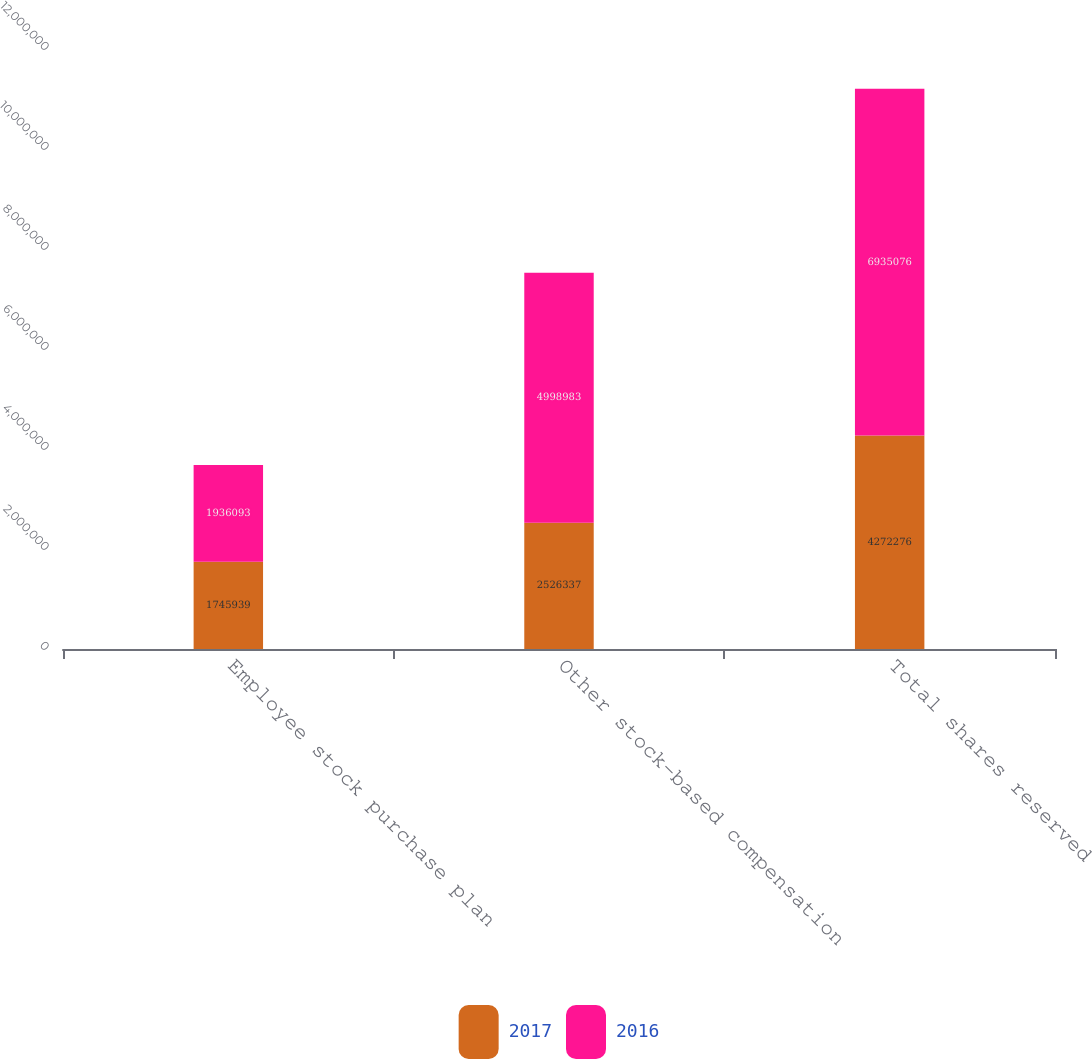Convert chart. <chart><loc_0><loc_0><loc_500><loc_500><stacked_bar_chart><ecel><fcel>Employee stock purchase plan<fcel>Other stock-based compensation<fcel>Total shares reserved<nl><fcel>2017<fcel>1.74594e+06<fcel>2.52634e+06<fcel>4.27228e+06<nl><fcel>2016<fcel>1.93609e+06<fcel>4.99898e+06<fcel>6.93508e+06<nl></chart> 